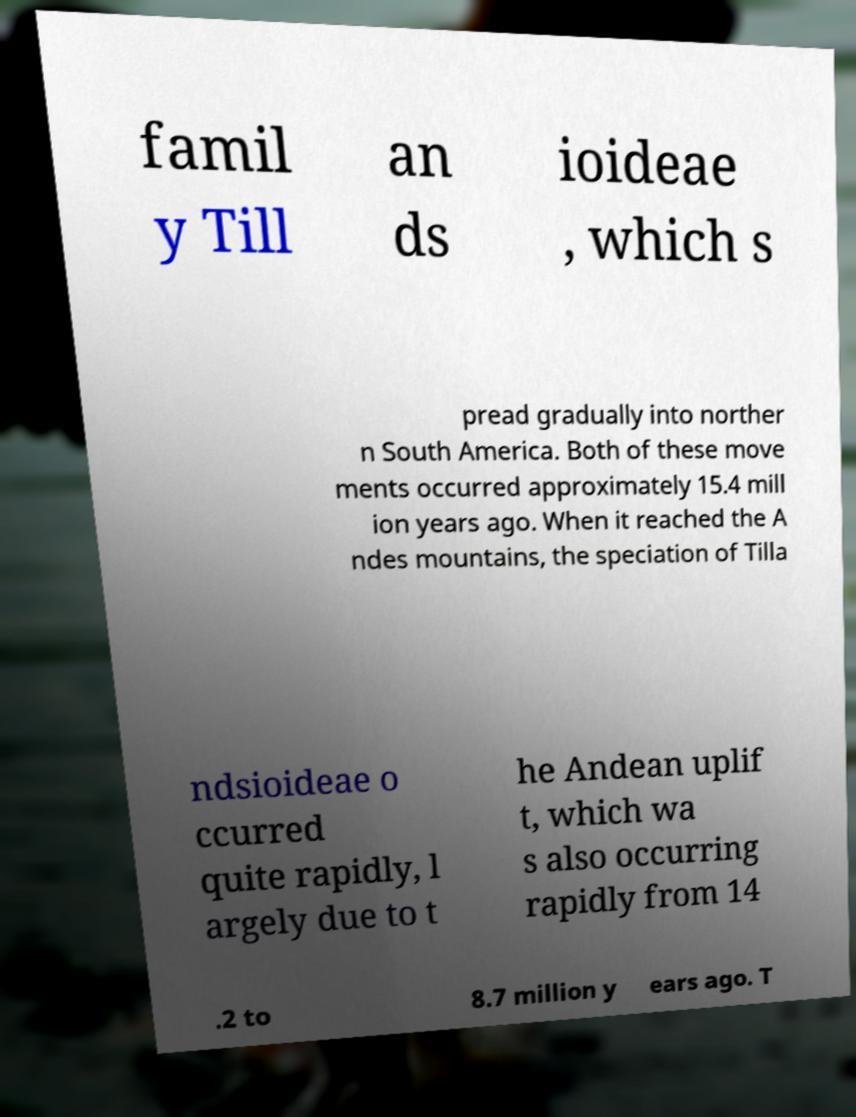Can you read and provide the text displayed in the image?This photo seems to have some interesting text. Can you extract and type it out for me? famil y Till an ds ioideae , which s pread gradually into norther n South America. Both of these move ments occurred approximately 15.4 mill ion years ago. When it reached the A ndes mountains, the speciation of Tilla ndsioideae o ccurred quite rapidly, l argely due to t he Andean uplif t, which wa s also occurring rapidly from 14 .2 to 8.7 million y ears ago. T 